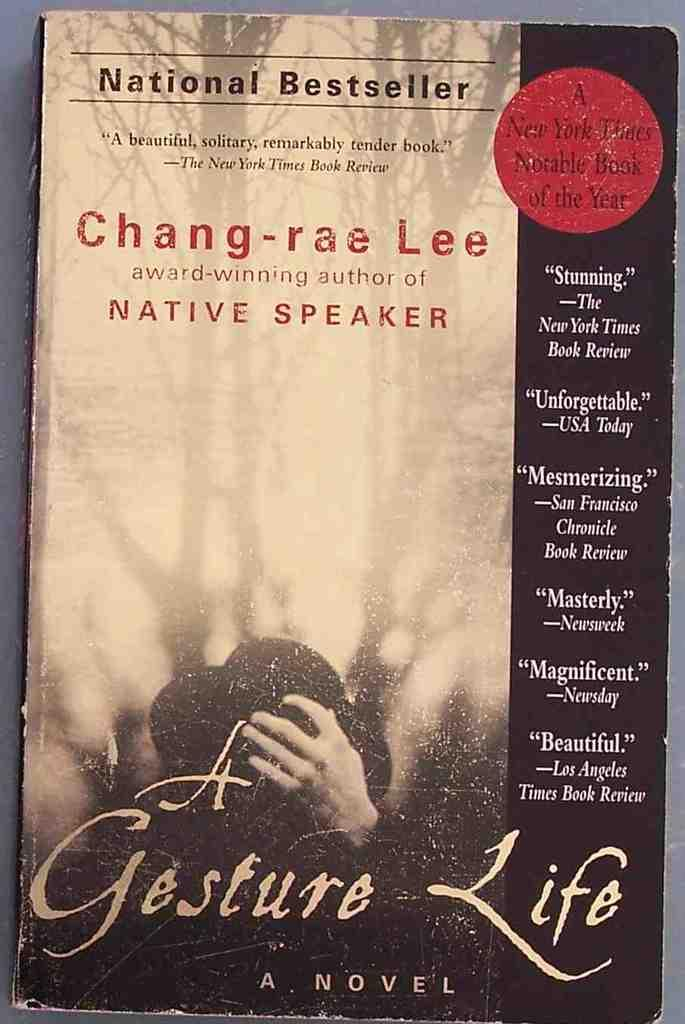<image>
Render a clear and concise summary of the photo. On a table rests a book by Chang-rae Lee titled A Gesture Life. 